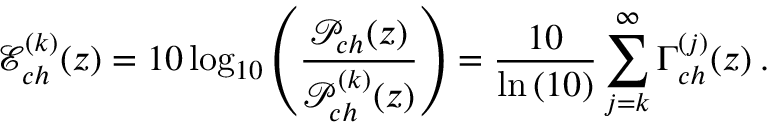<formula> <loc_0><loc_0><loc_500><loc_500>\mathcal { E } _ { c h } ^ { ( k ) } ( z ) = 1 0 \log _ { 1 0 } \left ( \frac { \mathcal { P } _ { c h } ( z ) } { \mathcal { P } _ { c h } ^ { ( k ) } ( z ) } \right ) = \frac { 1 0 } { \ln \left ( 1 0 \right ) } \sum _ { j = k } ^ { \infty } \Gamma _ { c h } ^ { ( j ) } ( z ) \, .</formula> 